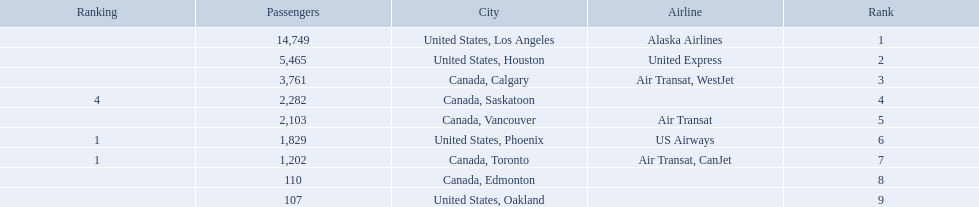Which airport has the least amount of passengers? 107. What airport has 107 passengers? United States, Oakland. What numbers are in the passengers column? 14,749, 5,465, 3,761, 2,282, 2,103, 1,829, 1,202, 110, 107. Which number is the lowest number in the passengers column? 107. What city is associated with this number? United States, Oakland. 